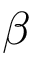<formula> <loc_0><loc_0><loc_500><loc_500>\beta</formula> 